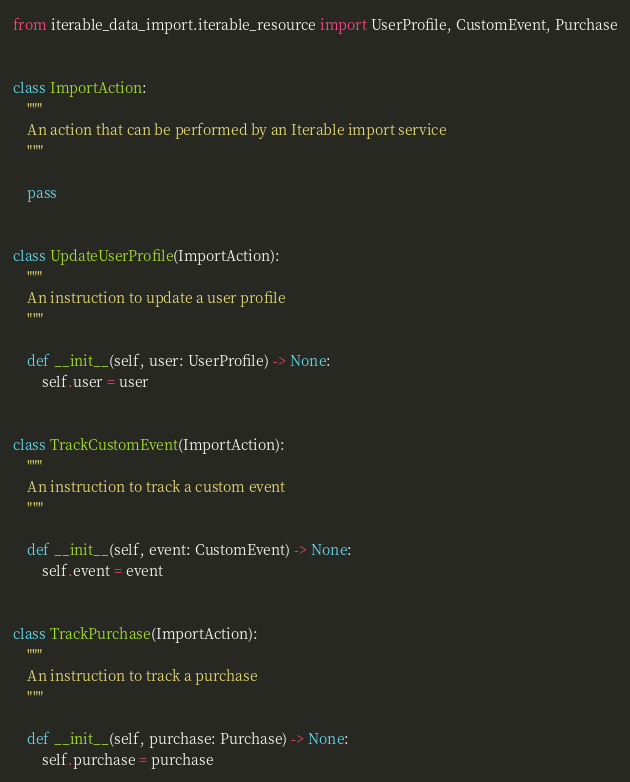<code> <loc_0><loc_0><loc_500><loc_500><_Python_>from iterable_data_import.iterable_resource import UserProfile, CustomEvent, Purchase


class ImportAction:
    """
    An action that can be performed by an Iterable import service
    """

    pass


class UpdateUserProfile(ImportAction):
    """
    An instruction to update a user profile
    """

    def __init__(self, user: UserProfile) -> None:
        self.user = user


class TrackCustomEvent(ImportAction):
    """
    An instruction to track a custom event
    """

    def __init__(self, event: CustomEvent) -> None:
        self.event = event


class TrackPurchase(ImportAction):
    """
    An instruction to track a purchase
    """

    def __init__(self, purchase: Purchase) -> None:
        self.purchase = purchase
</code> 